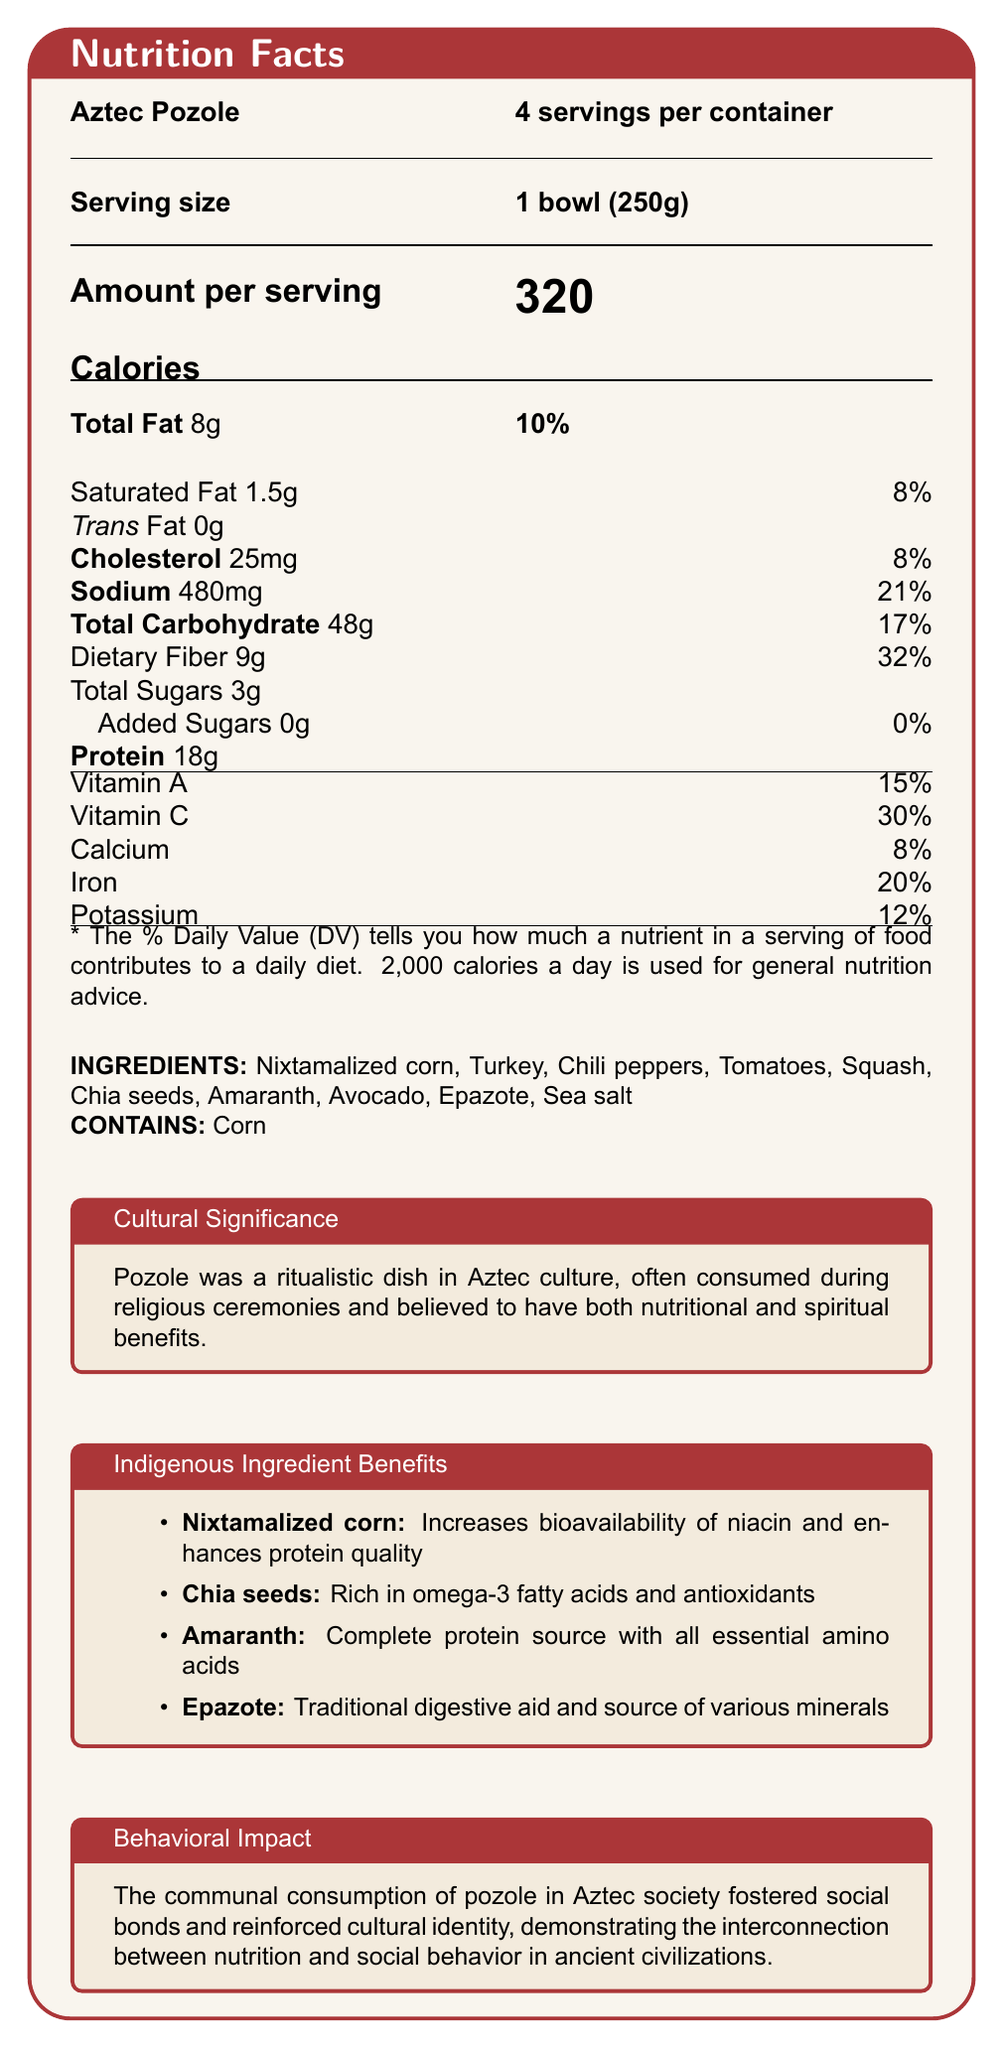what is the serving size of the Aztec Pozole? The serving size is clearly stated on the document as 1 bowl, which is 250 grams.
Answer: 1 bowl (250g) how many calories are in one serving of Aztec Pozole? The document lists the calorie content per serving as 320.
Answer: 320 calories what percentage of the daily value of dietary fiber does one serving of Aztec Pozole provide? The daily value percentage for dietary fiber is stated to be 32% in the document.
Answer: 32% how much protein is in one serving of Aztec Pozole? The protein content per serving is clearly stated to be 18 grams.
Answer: 18g what are the main benefits of nixtamalized corn according to the document? The document mentions that nixtamalized corn increases the bioavailability of niacin and enhances protein quality.
Answer: Increases bioavailability of niacin and enhances protein quality which ingredient in Aztec Pozole is rich in omega-3 fatty acids? A. Nixtamalized corn B. Chia seeds C. Amaranth D. Epazote The document states that chia seeds are rich in omega-3 fatty acids.
Answer: B what is the total fat content for one serving of Aztec Pozole? A. 8g B. 10g C. 18g D. 320g The total fat content per serving is listed as 8 grams.
Answer: A does the Aztec Pozole contain any added sugars? The document specifies that there are 0 grams of added sugars in the Aztec Pozole.
Answer: No does the document mention how many calories per day are generally used for nutrition advice? The document mentions that 2,000 calories per day is used for general nutrition advice.
Answer: Yes summarize the main idea of the document. The document outlines the nutritional content per serving of Aztec Pozole, cultural significance in Aztec rituals, and the health benefits of key ingredients like nixtamalized corn, chia seeds, amaranth, and epazote. It also mentions how communal consumption of the dish fostered social bonds in Aztec society.
Answer: The document provides detailed nutritional information about Aztec Pozole, integrates cultural and historical significance, and highlights the benefits of indigenous ingredients. how was pozole typically consumed in the Aztec culture? The document mentions that pozole was consumed during religious ceremonies but does not provide detailed information on the typical consumption customs in Aztec culture.
Answer: Not enough information 